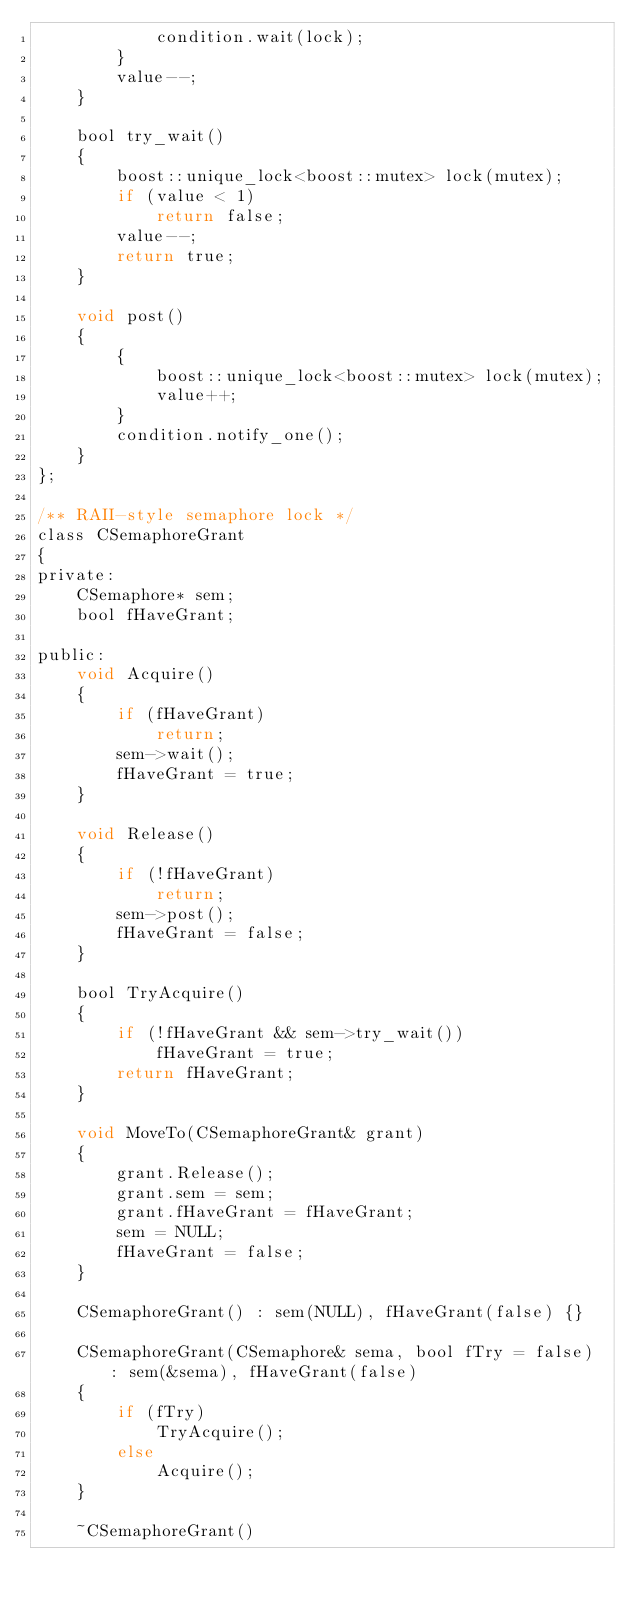Convert code to text. <code><loc_0><loc_0><loc_500><loc_500><_C_>            condition.wait(lock);
        }
        value--;
    }

    bool try_wait()
    {
        boost::unique_lock<boost::mutex> lock(mutex);
        if (value < 1)
            return false;
        value--;
        return true;
    }

    void post()
    {
        {
            boost::unique_lock<boost::mutex> lock(mutex);
            value++;
        }
        condition.notify_one();
    }
};

/** RAII-style semaphore lock */
class CSemaphoreGrant
{
private:
    CSemaphore* sem;
    bool fHaveGrant;

public:
    void Acquire()
    {
        if (fHaveGrant)
            return;
        sem->wait();
        fHaveGrant = true;
    }

    void Release()
    {
        if (!fHaveGrant)
            return;
        sem->post();
        fHaveGrant = false;
    }

    bool TryAcquire()
    {
        if (!fHaveGrant && sem->try_wait())
            fHaveGrant = true;
        return fHaveGrant;
    }

    void MoveTo(CSemaphoreGrant& grant)
    {
        grant.Release();
        grant.sem = sem;
        grant.fHaveGrant = fHaveGrant;
        sem = NULL;
        fHaveGrant = false;
    }

    CSemaphoreGrant() : sem(NULL), fHaveGrant(false) {}

    CSemaphoreGrant(CSemaphore& sema, bool fTry = false) : sem(&sema), fHaveGrant(false)
    {
        if (fTry)
            TryAcquire();
        else
            Acquire();
    }

    ~CSemaphoreGrant()</code> 